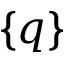<formula> <loc_0><loc_0><loc_500><loc_500>\{ { q } \}</formula> 